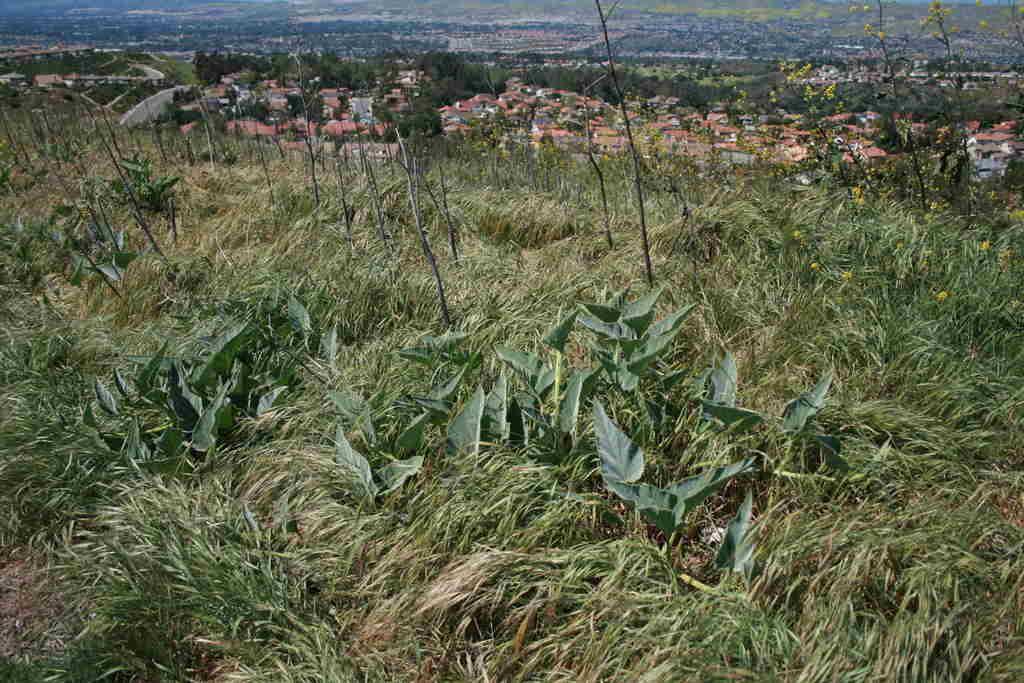Please provide a concise description of this image. At the bottom there are many plants and grass on the ground. At the top of the image there are many trees and buildings. On the right side there is a plant with some flowers which are in yellow color. 